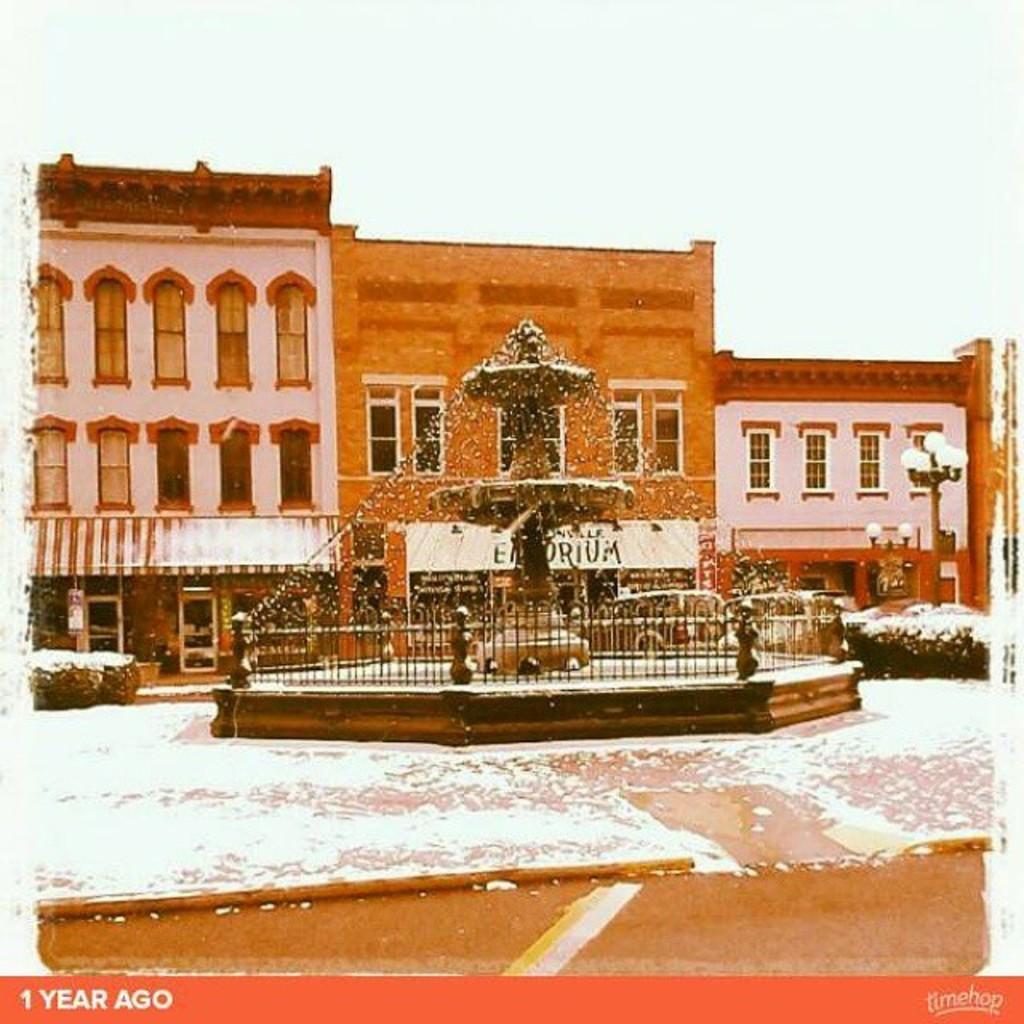Describe this image in one or two sentences. In this image I can see a fountain, background I can see a building in brown color, few light poles and the sky is in white color. 